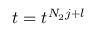Convert formula to latex. <formula><loc_0><loc_0><loc_500><loc_500>t = t ^ { N _ { 2 } j + l }</formula> 